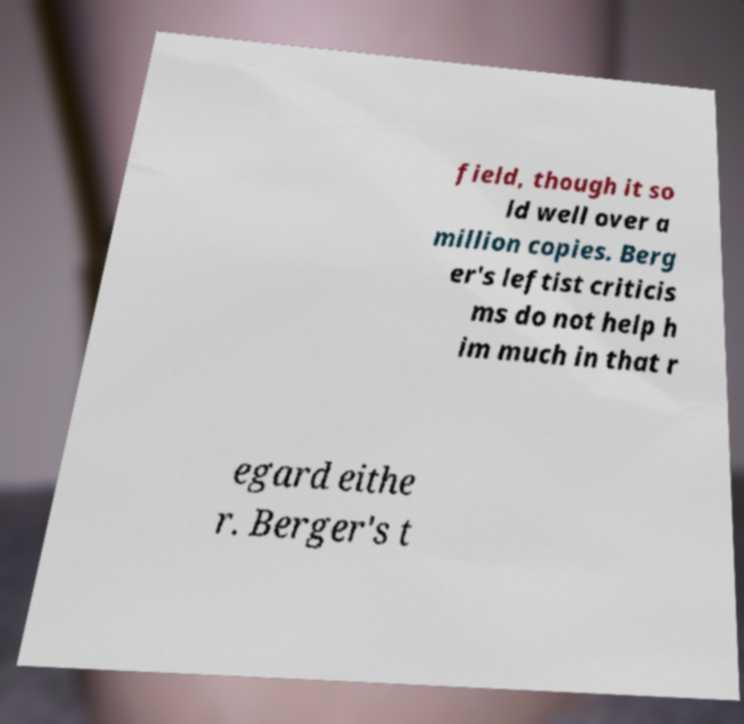What messages or text are displayed in this image? I need them in a readable, typed format. field, though it so ld well over a million copies. Berg er's leftist criticis ms do not help h im much in that r egard eithe r. Berger's t 